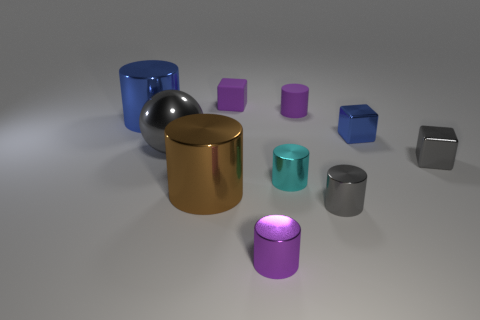Subtract all small metal cubes. How many cubes are left? 1 Subtract all gray balls. How many purple cylinders are left? 2 Subtract 2 cylinders. How many cylinders are left? 4 Subtract all brown cylinders. How many cylinders are left? 5 Subtract all cylinders. How many objects are left? 4 Subtract all cyan blocks. Subtract all cyan balls. How many blocks are left? 3 Subtract all large objects. Subtract all tiny blue rubber spheres. How many objects are left? 7 Add 3 tiny cyan metal things. How many tiny cyan metal things are left? 4 Add 6 blue metal objects. How many blue metal objects exist? 8 Subtract 1 purple cylinders. How many objects are left? 9 